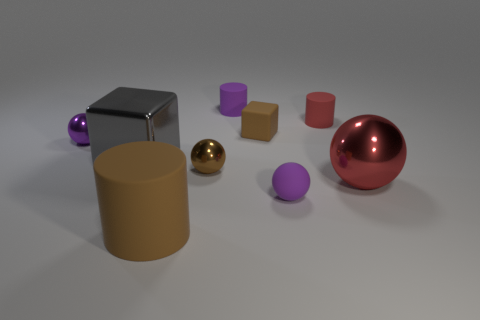Is there any other thing that is the same color as the large cylinder?
Give a very brief answer. Yes. There is a brown thing that is made of the same material as the red sphere; what is its shape?
Your answer should be very brief. Sphere. There is a cylinder in front of the purple sphere left of the gray object; what number of brown things are to the left of it?
Provide a short and direct response. 0. There is a big object that is both in front of the brown metal thing and left of the red rubber thing; what is its shape?
Offer a very short reply. Cylinder. Are there fewer gray shiny things that are behind the small red matte object than big things?
Offer a very short reply. Yes. How many big objects are either purple metal balls or purple blocks?
Make the answer very short. 0. What size is the red matte cylinder?
Provide a short and direct response. Small. Are there any other things that are the same material as the large red sphere?
Your answer should be compact. Yes. There is a purple shiny object; what number of big red shiny objects are in front of it?
Offer a terse response. 1. There is a rubber thing that is the same shape as the large red metal thing; what is its size?
Offer a terse response. Small. 